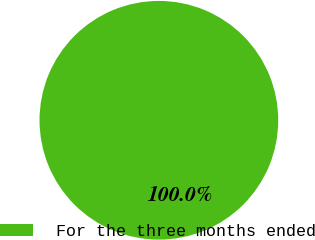Convert chart. <chart><loc_0><loc_0><loc_500><loc_500><pie_chart><fcel>For the three months ended<nl><fcel>100.0%<nl></chart> 